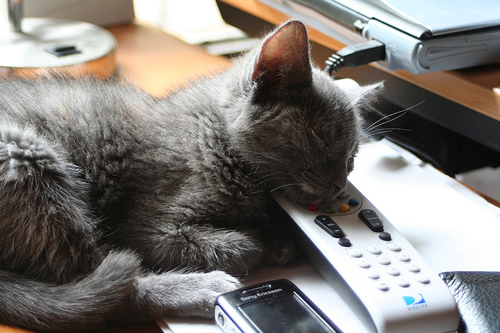Identify the text contained in this image. Sony Ericssion 